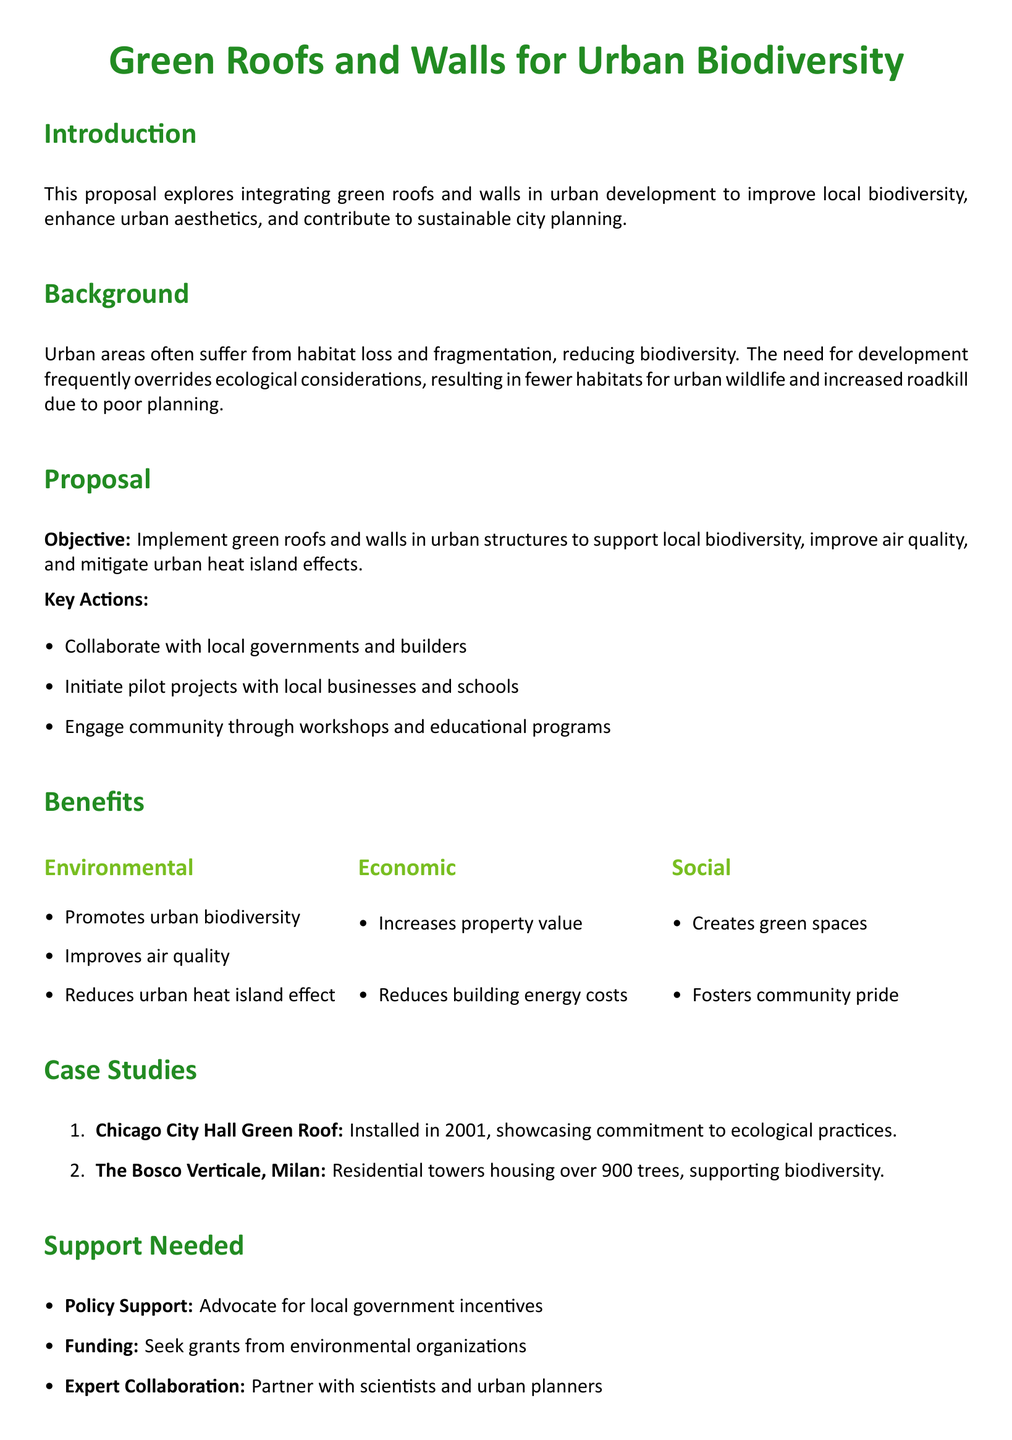What is the primary objective of the proposal? The primary objective is to implement green roofs and walls in urban structures to support local biodiversity, improve air quality, and mitigate urban heat island effects.
Answer: Implement green roofs and walls What is one environmental benefit mentioned? An environmental benefit mentioned is promoting urban biodiversity, which is explicitly listed in the benefits section of the document.
Answer: Promotes urban biodiversity In which city was the City Hall Green Roof installed? The document specifically states that the City Hall Green Roof is located in Chicago, providing a clear answer to the question about its location.
Answer: Chicago What type of support is needed from local governments? The document lists policy support as a needed action from local governments in the support needed section.
Answer: Policy Support What year was the Chicago City Hall Green Roof installed? The document specifies that the Chicago City Hall Green Roof was installed in 2001, providing a precise year for reference.
Answer: 2001 What two types of organizations should funding be sought from? The proposal suggests seeking grants from environmental organizations, which implies two primary sources for funding.
Answer: Environmental organizations What is one of the pilot project partners mentioned? The proposal highlights local businesses and schools as potential partners for initiating pilot projects, making it clear who could be involved.
Answer: Local businesses and schools What visual element is used to enhance the proposal's design? The use of color is evident throughout the document, particularly forest green and leaf green for section titles, thereby adding an aesthetic touch.
Answer: Color How many case studies are presented in the proposal? The document explicitly enumerates two case studies as examples supporting the proposal’s recommendations for green roofs and walls.
Answer: Two 